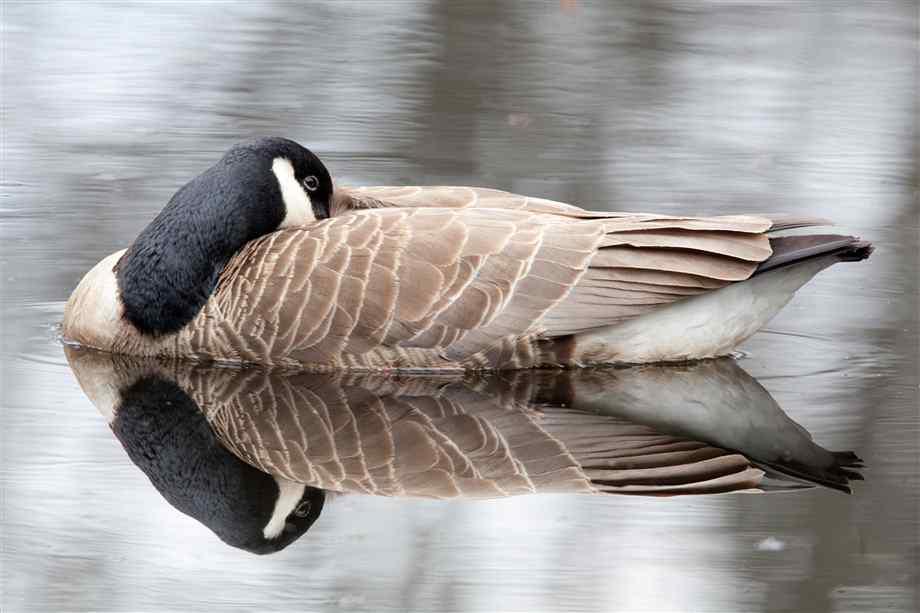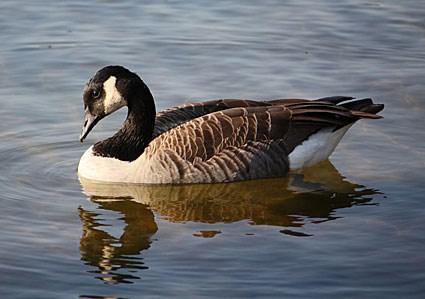The first image is the image on the left, the second image is the image on the right. For the images displayed, is the sentence "The left image contains at least two ducks." factually correct? Answer yes or no. No. The first image is the image on the left, the second image is the image on the right. Evaluate the accuracy of this statement regarding the images: "Each image shows one goose, and in one image the goose is on water and posed with its neck curved back.". Is it true? Answer yes or no. Yes. 